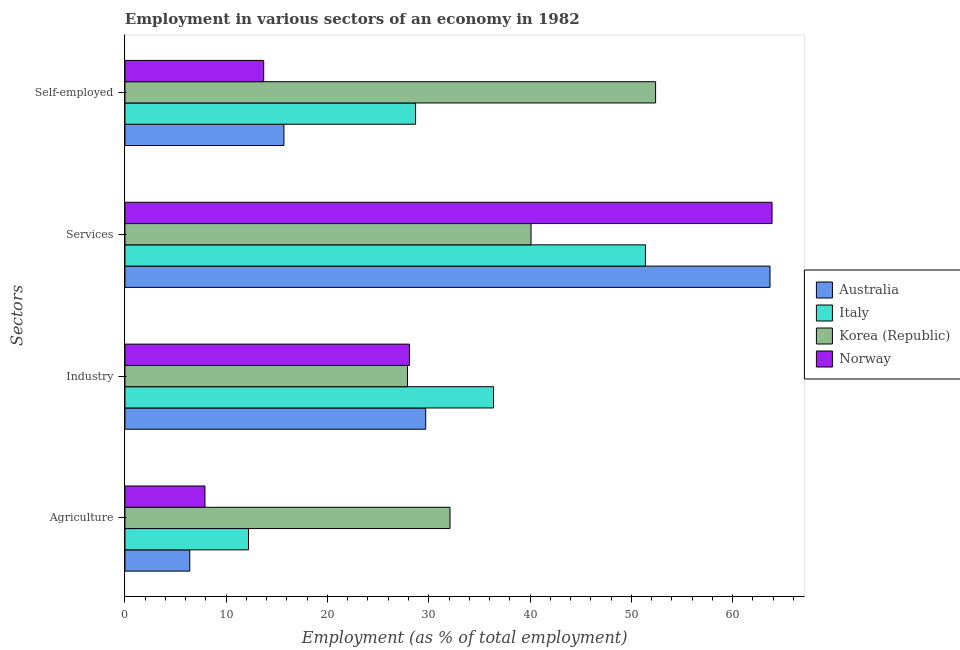Are the number of bars on each tick of the Y-axis equal?
Keep it short and to the point. Yes. How many bars are there on the 2nd tick from the top?
Offer a terse response. 4. What is the label of the 2nd group of bars from the top?
Your response must be concise. Services. What is the percentage of self employed workers in Norway?
Give a very brief answer. 13.7. Across all countries, what is the maximum percentage of workers in services?
Make the answer very short. 63.9. Across all countries, what is the minimum percentage of self employed workers?
Offer a terse response. 13.7. In which country was the percentage of workers in services minimum?
Keep it short and to the point. Korea (Republic). What is the total percentage of self employed workers in the graph?
Provide a short and direct response. 110.5. What is the difference between the percentage of workers in industry in Norway and that in Korea (Republic)?
Provide a short and direct response. 0.2. What is the difference between the percentage of workers in services in Norway and the percentage of self employed workers in Italy?
Offer a very short reply. 35.2. What is the average percentage of self employed workers per country?
Offer a terse response. 27.63. What is the difference between the percentage of workers in industry and percentage of self employed workers in Norway?
Your answer should be very brief. 14.4. What is the ratio of the percentage of self employed workers in Italy to that in Norway?
Ensure brevity in your answer.  2.09. What is the difference between the highest and the second highest percentage of workers in agriculture?
Keep it short and to the point. 19.9. What is the difference between the highest and the lowest percentage of workers in industry?
Your answer should be compact. 8.5. In how many countries, is the percentage of workers in agriculture greater than the average percentage of workers in agriculture taken over all countries?
Your answer should be very brief. 1. Is the sum of the percentage of workers in industry in Italy and Norway greater than the maximum percentage of self employed workers across all countries?
Your response must be concise. Yes. Is it the case that in every country, the sum of the percentage of workers in services and percentage of workers in agriculture is greater than the sum of percentage of workers in industry and percentage of self employed workers?
Offer a terse response. No. What does the 4th bar from the bottom in Industry represents?
Offer a terse response. Norway. Is it the case that in every country, the sum of the percentage of workers in agriculture and percentage of workers in industry is greater than the percentage of workers in services?
Provide a succinct answer. No. Are all the bars in the graph horizontal?
Keep it short and to the point. Yes. How many countries are there in the graph?
Ensure brevity in your answer.  4. What is the difference between two consecutive major ticks on the X-axis?
Your answer should be compact. 10. Are the values on the major ticks of X-axis written in scientific E-notation?
Ensure brevity in your answer.  No. Does the graph contain any zero values?
Keep it short and to the point. No. Where does the legend appear in the graph?
Provide a short and direct response. Center right. How are the legend labels stacked?
Your answer should be compact. Vertical. What is the title of the graph?
Your answer should be compact. Employment in various sectors of an economy in 1982. What is the label or title of the X-axis?
Your answer should be compact. Employment (as % of total employment). What is the label or title of the Y-axis?
Offer a very short reply. Sectors. What is the Employment (as % of total employment) in Australia in Agriculture?
Provide a short and direct response. 6.4. What is the Employment (as % of total employment) of Italy in Agriculture?
Provide a succinct answer. 12.2. What is the Employment (as % of total employment) of Korea (Republic) in Agriculture?
Provide a short and direct response. 32.1. What is the Employment (as % of total employment) in Norway in Agriculture?
Provide a succinct answer. 7.9. What is the Employment (as % of total employment) of Australia in Industry?
Provide a short and direct response. 29.7. What is the Employment (as % of total employment) in Italy in Industry?
Your response must be concise. 36.4. What is the Employment (as % of total employment) in Korea (Republic) in Industry?
Your response must be concise. 27.9. What is the Employment (as % of total employment) in Norway in Industry?
Provide a short and direct response. 28.1. What is the Employment (as % of total employment) in Australia in Services?
Provide a short and direct response. 63.7. What is the Employment (as % of total employment) in Italy in Services?
Your answer should be very brief. 51.4. What is the Employment (as % of total employment) of Korea (Republic) in Services?
Provide a succinct answer. 40.1. What is the Employment (as % of total employment) of Norway in Services?
Keep it short and to the point. 63.9. What is the Employment (as % of total employment) in Australia in Self-employed?
Make the answer very short. 15.7. What is the Employment (as % of total employment) in Italy in Self-employed?
Offer a terse response. 28.7. What is the Employment (as % of total employment) of Korea (Republic) in Self-employed?
Offer a very short reply. 52.4. What is the Employment (as % of total employment) in Norway in Self-employed?
Offer a very short reply. 13.7. Across all Sectors, what is the maximum Employment (as % of total employment) in Australia?
Offer a terse response. 63.7. Across all Sectors, what is the maximum Employment (as % of total employment) of Italy?
Make the answer very short. 51.4. Across all Sectors, what is the maximum Employment (as % of total employment) of Korea (Republic)?
Offer a terse response. 52.4. Across all Sectors, what is the maximum Employment (as % of total employment) in Norway?
Offer a terse response. 63.9. Across all Sectors, what is the minimum Employment (as % of total employment) of Australia?
Make the answer very short. 6.4. Across all Sectors, what is the minimum Employment (as % of total employment) of Italy?
Make the answer very short. 12.2. Across all Sectors, what is the minimum Employment (as % of total employment) in Korea (Republic)?
Your answer should be compact. 27.9. Across all Sectors, what is the minimum Employment (as % of total employment) in Norway?
Give a very brief answer. 7.9. What is the total Employment (as % of total employment) of Australia in the graph?
Your response must be concise. 115.5. What is the total Employment (as % of total employment) of Italy in the graph?
Make the answer very short. 128.7. What is the total Employment (as % of total employment) of Korea (Republic) in the graph?
Your answer should be compact. 152.5. What is the total Employment (as % of total employment) of Norway in the graph?
Your answer should be compact. 113.6. What is the difference between the Employment (as % of total employment) of Australia in Agriculture and that in Industry?
Make the answer very short. -23.3. What is the difference between the Employment (as % of total employment) of Italy in Agriculture and that in Industry?
Ensure brevity in your answer.  -24.2. What is the difference between the Employment (as % of total employment) in Norway in Agriculture and that in Industry?
Offer a terse response. -20.2. What is the difference between the Employment (as % of total employment) of Australia in Agriculture and that in Services?
Your answer should be very brief. -57.3. What is the difference between the Employment (as % of total employment) in Italy in Agriculture and that in Services?
Provide a succinct answer. -39.2. What is the difference between the Employment (as % of total employment) in Korea (Republic) in Agriculture and that in Services?
Ensure brevity in your answer.  -8. What is the difference between the Employment (as % of total employment) in Norway in Agriculture and that in Services?
Keep it short and to the point. -56. What is the difference between the Employment (as % of total employment) in Italy in Agriculture and that in Self-employed?
Provide a succinct answer. -16.5. What is the difference between the Employment (as % of total employment) in Korea (Republic) in Agriculture and that in Self-employed?
Provide a short and direct response. -20.3. What is the difference between the Employment (as % of total employment) in Australia in Industry and that in Services?
Offer a very short reply. -34. What is the difference between the Employment (as % of total employment) of Korea (Republic) in Industry and that in Services?
Keep it short and to the point. -12.2. What is the difference between the Employment (as % of total employment) of Norway in Industry and that in Services?
Offer a terse response. -35.8. What is the difference between the Employment (as % of total employment) in Korea (Republic) in Industry and that in Self-employed?
Keep it short and to the point. -24.5. What is the difference between the Employment (as % of total employment) in Norway in Industry and that in Self-employed?
Make the answer very short. 14.4. What is the difference between the Employment (as % of total employment) in Italy in Services and that in Self-employed?
Offer a terse response. 22.7. What is the difference between the Employment (as % of total employment) in Norway in Services and that in Self-employed?
Offer a very short reply. 50.2. What is the difference between the Employment (as % of total employment) in Australia in Agriculture and the Employment (as % of total employment) in Korea (Republic) in Industry?
Your answer should be very brief. -21.5. What is the difference between the Employment (as % of total employment) in Australia in Agriculture and the Employment (as % of total employment) in Norway in Industry?
Provide a short and direct response. -21.7. What is the difference between the Employment (as % of total employment) in Italy in Agriculture and the Employment (as % of total employment) in Korea (Republic) in Industry?
Your response must be concise. -15.7. What is the difference between the Employment (as % of total employment) of Italy in Agriculture and the Employment (as % of total employment) of Norway in Industry?
Make the answer very short. -15.9. What is the difference between the Employment (as % of total employment) in Korea (Republic) in Agriculture and the Employment (as % of total employment) in Norway in Industry?
Your answer should be compact. 4. What is the difference between the Employment (as % of total employment) in Australia in Agriculture and the Employment (as % of total employment) in Italy in Services?
Give a very brief answer. -45. What is the difference between the Employment (as % of total employment) in Australia in Agriculture and the Employment (as % of total employment) in Korea (Republic) in Services?
Provide a short and direct response. -33.7. What is the difference between the Employment (as % of total employment) in Australia in Agriculture and the Employment (as % of total employment) in Norway in Services?
Ensure brevity in your answer.  -57.5. What is the difference between the Employment (as % of total employment) of Italy in Agriculture and the Employment (as % of total employment) of Korea (Republic) in Services?
Make the answer very short. -27.9. What is the difference between the Employment (as % of total employment) of Italy in Agriculture and the Employment (as % of total employment) of Norway in Services?
Your response must be concise. -51.7. What is the difference between the Employment (as % of total employment) of Korea (Republic) in Agriculture and the Employment (as % of total employment) of Norway in Services?
Ensure brevity in your answer.  -31.8. What is the difference between the Employment (as % of total employment) in Australia in Agriculture and the Employment (as % of total employment) in Italy in Self-employed?
Offer a terse response. -22.3. What is the difference between the Employment (as % of total employment) in Australia in Agriculture and the Employment (as % of total employment) in Korea (Republic) in Self-employed?
Offer a terse response. -46. What is the difference between the Employment (as % of total employment) in Australia in Agriculture and the Employment (as % of total employment) in Norway in Self-employed?
Make the answer very short. -7.3. What is the difference between the Employment (as % of total employment) of Italy in Agriculture and the Employment (as % of total employment) of Korea (Republic) in Self-employed?
Ensure brevity in your answer.  -40.2. What is the difference between the Employment (as % of total employment) of Italy in Agriculture and the Employment (as % of total employment) of Norway in Self-employed?
Ensure brevity in your answer.  -1.5. What is the difference between the Employment (as % of total employment) in Australia in Industry and the Employment (as % of total employment) in Italy in Services?
Provide a short and direct response. -21.7. What is the difference between the Employment (as % of total employment) of Australia in Industry and the Employment (as % of total employment) of Korea (Republic) in Services?
Provide a short and direct response. -10.4. What is the difference between the Employment (as % of total employment) of Australia in Industry and the Employment (as % of total employment) of Norway in Services?
Make the answer very short. -34.2. What is the difference between the Employment (as % of total employment) in Italy in Industry and the Employment (as % of total employment) in Norway in Services?
Offer a terse response. -27.5. What is the difference between the Employment (as % of total employment) of Korea (Republic) in Industry and the Employment (as % of total employment) of Norway in Services?
Provide a succinct answer. -36. What is the difference between the Employment (as % of total employment) of Australia in Industry and the Employment (as % of total employment) of Korea (Republic) in Self-employed?
Make the answer very short. -22.7. What is the difference between the Employment (as % of total employment) of Italy in Industry and the Employment (as % of total employment) of Korea (Republic) in Self-employed?
Your answer should be compact. -16. What is the difference between the Employment (as % of total employment) in Italy in Industry and the Employment (as % of total employment) in Norway in Self-employed?
Your answer should be compact. 22.7. What is the difference between the Employment (as % of total employment) in Korea (Republic) in Industry and the Employment (as % of total employment) in Norway in Self-employed?
Make the answer very short. 14.2. What is the difference between the Employment (as % of total employment) of Australia in Services and the Employment (as % of total employment) of Norway in Self-employed?
Offer a very short reply. 50. What is the difference between the Employment (as % of total employment) of Italy in Services and the Employment (as % of total employment) of Norway in Self-employed?
Make the answer very short. 37.7. What is the difference between the Employment (as % of total employment) of Korea (Republic) in Services and the Employment (as % of total employment) of Norway in Self-employed?
Make the answer very short. 26.4. What is the average Employment (as % of total employment) in Australia per Sectors?
Offer a very short reply. 28.88. What is the average Employment (as % of total employment) of Italy per Sectors?
Make the answer very short. 32.17. What is the average Employment (as % of total employment) in Korea (Republic) per Sectors?
Your answer should be compact. 38.12. What is the average Employment (as % of total employment) in Norway per Sectors?
Your answer should be very brief. 28.4. What is the difference between the Employment (as % of total employment) in Australia and Employment (as % of total employment) in Italy in Agriculture?
Offer a terse response. -5.8. What is the difference between the Employment (as % of total employment) in Australia and Employment (as % of total employment) in Korea (Republic) in Agriculture?
Give a very brief answer. -25.7. What is the difference between the Employment (as % of total employment) of Australia and Employment (as % of total employment) of Norway in Agriculture?
Offer a very short reply. -1.5. What is the difference between the Employment (as % of total employment) in Italy and Employment (as % of total employment) in Korea (Republic) in Agriculture?
Offer a terse response. -19.9. What is the difference between the Employment (as % of total employment) in Italy and Employment (as % of total employment) in Norway in Agriculture?
Your response must be concise. 4.3. What is the difference between the Employment (as % of total employment) of Korea (Republic) and Employment (as % of total employment) of Norway in Agriculture?
Make the answer very short. 24.2. What is the difference between the Employment (as % of total employment) in Australia and Employment (as % of total employment) in Italy in Industry?
Your answer should be very brief. -6.7. What is the difference between the Employment (as % of total employment) of Australia and Employment (as % of total employment) of Korea (Republic) in Industry?
Provide a short and direct response. 1.8. What is the difference between the Employment (as % of total employment) of Australia and Employment (as % of total employment) of Norway in Industry?
Make the answer very short. 1.6. What is the difference between the Employment (as % of total employment) in Italy and Employment (as % of total employment) in Korea (Republic) in Industry?
Offer a very short reply. 8.5. What is the difference between the Employment (as % of total employment) in Korea (Republic) and Employment (as % of total employment) in Norway in Industry?
Your answer should be compact. -0.2. What is the difference between the Employment (as % of total employment) in Australia and Employment (as % of total employment) in Italy in Services?
Provide a succinct answer. 12.3. What is the difference between the Employment (as % of total employment) in Australia and Employment (as % of total employment) in Korea (Republic) in Services?
Your answer should be very brief. 23.6. What is the difference between the Employment (as % of total employment) in Australia and Employment (as % of total employment) in Norway in Services?
Your answer should be very brief. -0.2. What is the difference between the Employment (as % of total employment) in Italy and Employment (as % of total employment) in Norway in Services?
Your answer should be compact. -12.5. What is the difference between the Employment (as % of total employment) of Korea (Republic) and Employment (as % of total employment) of Norway in Services?
Offer a terse response. -23.8. What is the difference between the Employment (as % of total employment) of Australia and Employment (as % of total employment) of Korea (Republic) in Self-employed?
Make the answer very short. -36.7. What is the difference between the Employment (as % of total employment) in Italy and Employment (as % of total employment) in Korea (Republic) in Self-employed?
Provide a succinct answer. -23.7. What is the difference between the Employment (as % of total employment) in Korea (Republic) and Employment (as % of total employment) in Norway in Self-employed?
Provide a short and direct response. 38.7. What is the ratio of the Employment (as % of total employment) in Australia in Agriculture to that in Industry?
Your response must be concise. 0.22. What is the ratio of the Employment (as % of total employment) of Italy in Agriculture to that in Industry?
Your answer should be compact. 0.34. What is the ratio of the Employment (as % of total employment) in Korea (Republic) in Agriculture to that in Industry?
Provide a succinct answer. 1.15. What is the ratio of the Employment (as % of total employment) of Norway in Agriculture to that in Industry?
Offer a very short reply. 0.28. What is the ratio of the Employment (as % of total employment) in Australia in Agriculture to that in Services?
Ensure brevity in your answer.  0.1. What is the ratio of the Employment (as % of total employment) in Italy in Agriculture to that in Services?
Offer a very short reply. 0.24. What is the ratio of the Employment (as % of total employment) in Korea (Republic) in Agriculture to that in Services?
Ensure brevity in your answer.  0.8. What is the ratio of the Employment (as % of total employment) of Norway in Agriculture to that in Services?
Keep it short and to the point. 0.12. What is the ratio of the Employment (as % of total employment) of Australia in Agriculture to that in Self-employed?
Keep it short and to the point. 0.41. What is the ratio of the Employment (as % of total employment) in Italy in Agriculture to that in Self-employed?
Ensure brevity in your answer.  0.43. What is the ratio of the Employment (as % of total employment) of Korea (Republic) in Agriculture to that in Self-employed?
Your answer should be very brief. 0.61. What is the ratio of the Employment (as % of total employment) in Norway in Agriculture to that in Self-employed?
Your response must be concise. 0.58. What is the ratio of the Employment (as % of total employment) in Australia in Industry to that in Services?
Your answer should be compact. 0.47. What is the ratio of the Employment (as % of total employment) in Italy in Industry to that in Services?
Offer a very short reply. 0.71. What is the ratio of the Employment (as % of total employment) in Korea (Republic) in Industry to that in Services?
Offer a very short reply. 0.7. What is the ratio of the Employment (as % of total employment) of Norway in Industry to that in Services?
Your answer should be compact. 0.44. What is the ratio of the Employment (as % of total employment) in Australia in Industry to that in Self-employed?
Provide a succinct answer. 1.89. What is the ratio of the Employment (as % of total employment) of Italy in Industry to that in Self-employed?
Your answer should be very brief. 1.27. What is the ratio of the Employment (as % of total employment) of Korea (Republic) in Industry to that in Self-employed?
Offer a terse response. 0.53. What is the ratio of the Employment (as % of total employment) of Norway in Industry to that in Self-employed?
Your answer should be compact. 2.05. What is the ratio of the Employment (as % of total employment) in Australia in Services to that in Self-employed?
Offer a terse response. 4.06. What is the ratio of the Employment (as % of total employment) in Italy in Services to that in Self-employed?
Your answer should be compact. 1.79. What is the ratio of the Employment (as % of total employment) of Korea (Republic) in Services to that in Self-employed?
Your answer should be very brief. 0.77. What is the ratio of the Employment (as % of total employment) in Norway in Services to that in Self-employed?
Provide a succinct answer. 4.66. What is the difference between the highest and the second highest Employment (as % of total employment) in Norway?
Provide a short and direct response. 35.8. What is the difference between the highest and the lowest Employment (as % of total employment) in Australia?
Keep it short and to the point. 57.3. What is the difference between the highest and the lowest Employment (as % of total employment) of Italy?
Ensure brevity in your answer.  39.2. What is the difference between the highest and the lowest Employment (as % of total employment) of Korea (Republic)?
Ensure brevity in your answer.  24.5. 